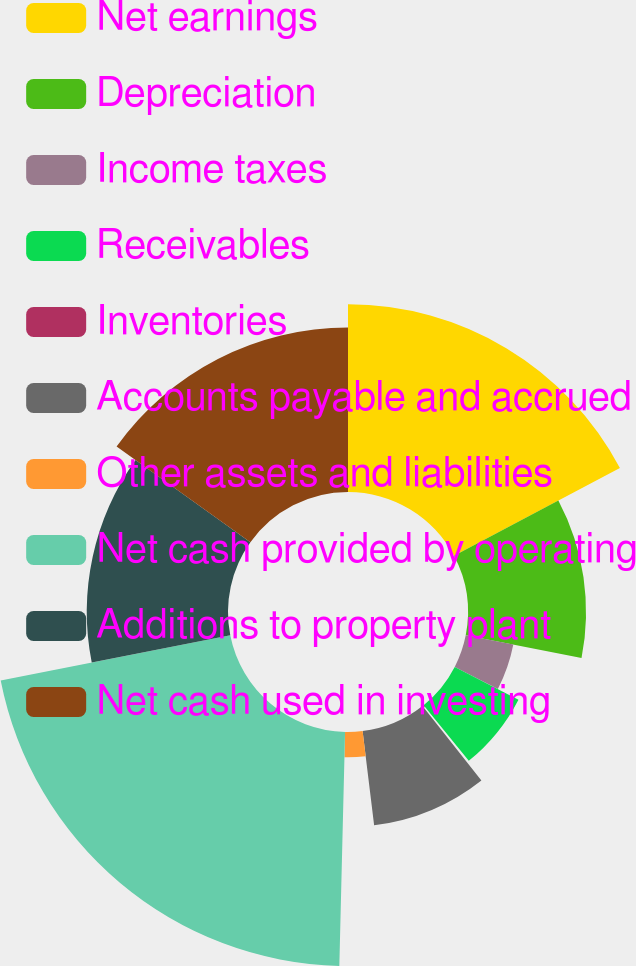<chart> <loc_0><loc_0><loc_500><loc_500><pie_chart><fcel>Net earnings<fcel>Depreciation<fcel>Income taxes<fcel>Receivables<fcel>Inventories<fcel>Accounts payable and accrued<fcel>Other assets and liabilities<fcel>Net cash provided by operating<fcel>Additions to property plant<fcel>Net cash used in investing<nl><fcel>17.25%<fcel>10.85%<fcel>4.46%<fcel>6.59%<fcel>0.19%<fcel>8.72%<fcel>2.33%<fcel>21.51%<fcel>12.98%<fcel>15.12%<nl></chart> 